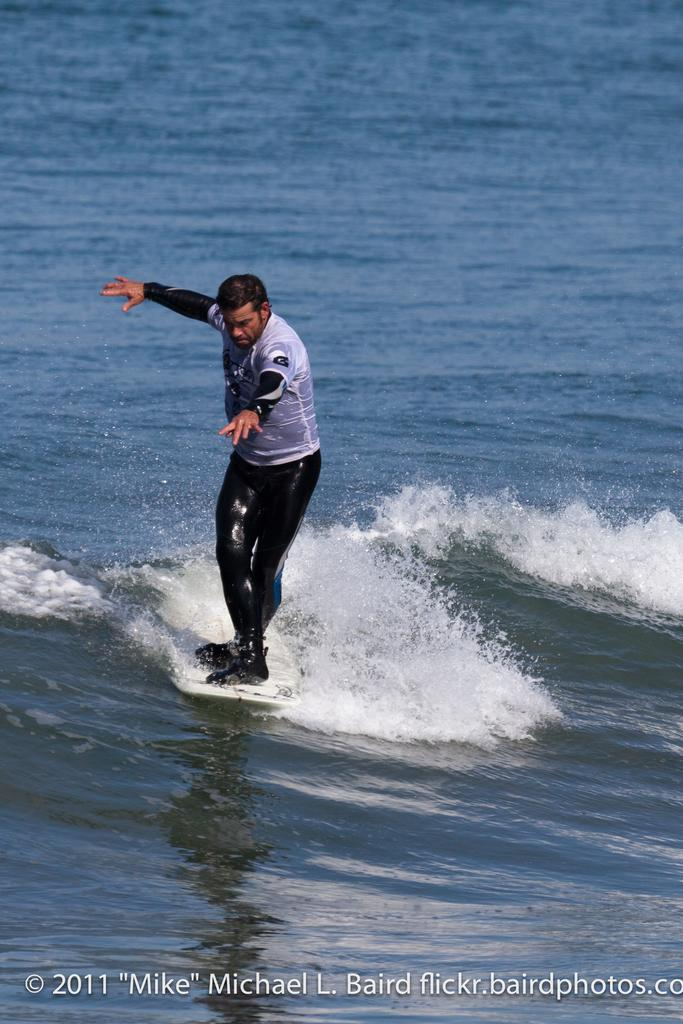Who is the main subject in the image? There is a man in the image. What is the man wearing? The man is wearing a white t-shirt. What activity is the man engaged in? The man is surfing on the water. What type of environment is visible in the image? There is sea water visible in the image. What type of insurance does the man have for his surfboard in the image? There is no information about insurance for the surfboard in the image. 